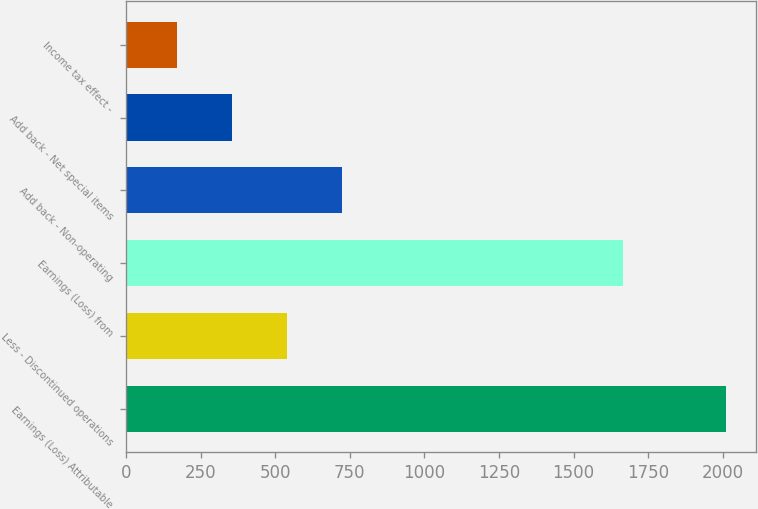<chart> <loc_0><loc_0><loc_500><loc_500><bar_chart><fcel>Earnings (Loss) Attributable<fcel>Less - Discontinued operations<fcel>Earnings (Loss) from<fcel>Add back - Non-operating<fcel>Add back - Net special items<fcel>Income tax effect -<nl><fcel>2012<fcel>539.2<fcel>1667<fcel>723.3<fcel>355.1<fcel>171<nl></chart> 